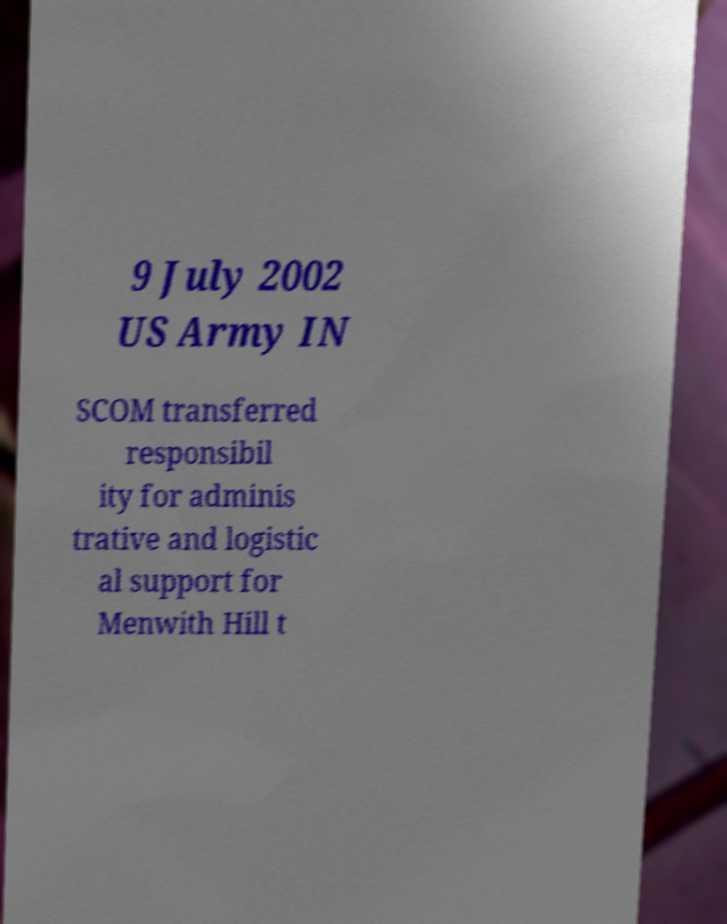I need the written content from this picture converted into text. Can you do that? 9 July 2002 US Army IN SCOM transferred responsibil ity for adminis trative and logistic al support for Menwith Hill t 